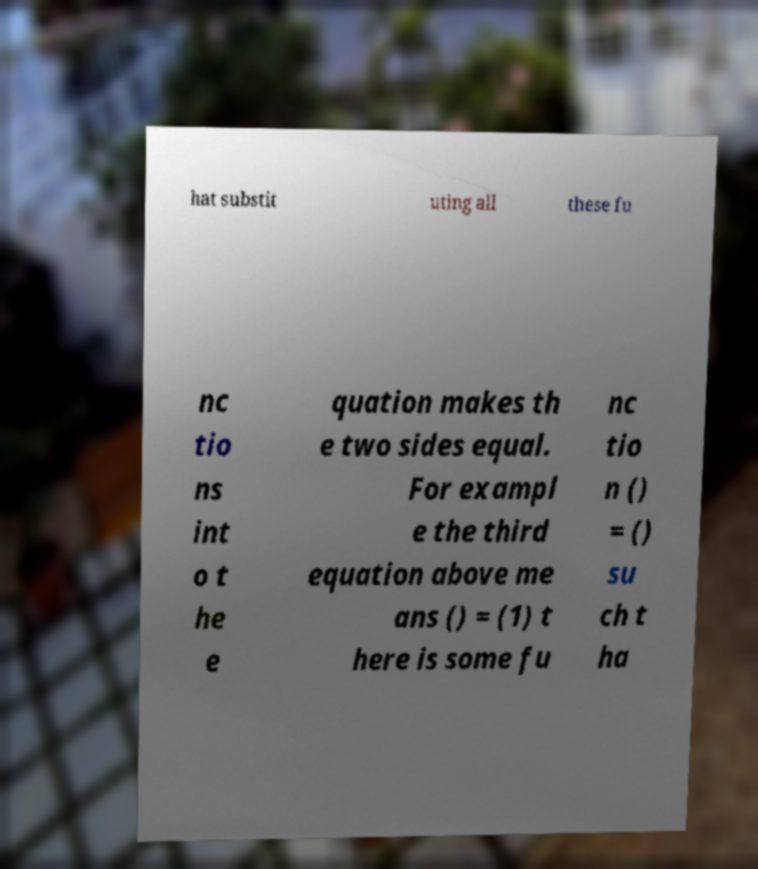Please read and relay the text visible in this image. What does it say? hat substit uting all these fu nc tio ns int o t he e quation makes th e two sides equal. For exampl e the third equation above me ans () = (1) t here is some fu nc tio n () = () su ch t ha 